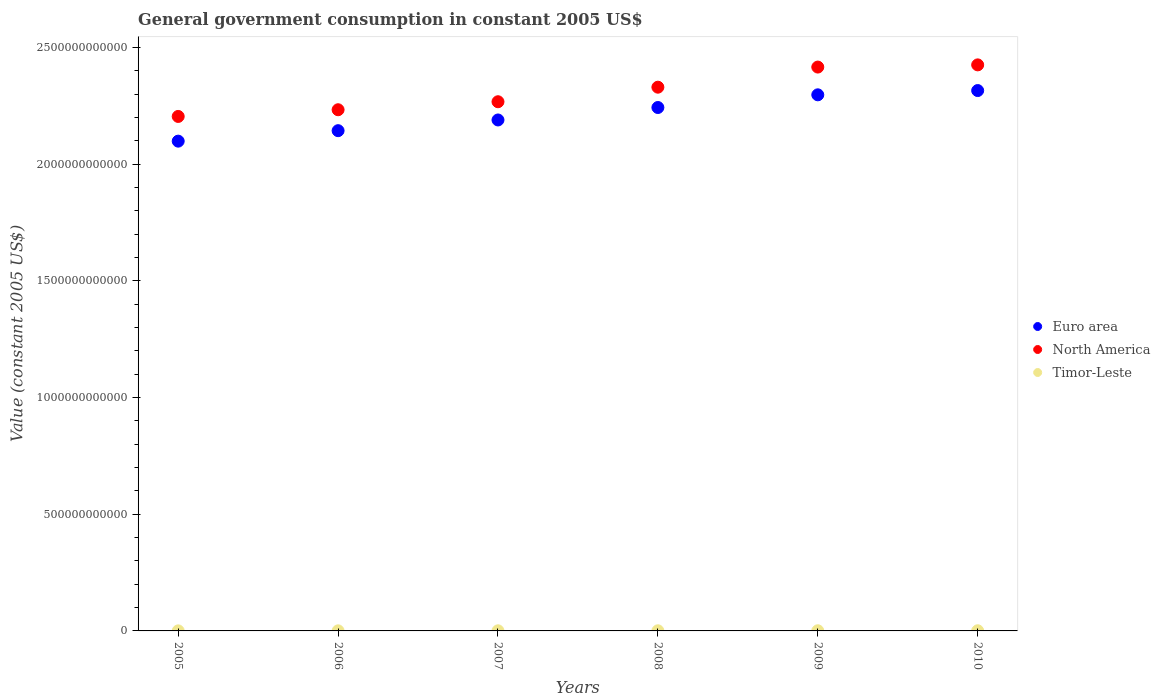What is the government conusmption in North America in 2010?
Give a very brief answer. 2.42e+12. Across all years, what is the maximum government conusmption in Euro area?
Your response must be concise. 2.31e+12. Across all years, what is the minimum government conusmption in North America?
Give a very brief answer. 2.20e+12. In which year was the government conusmption in Euro area minimum?
Provide a short and direct response. 2005. What is the total government conusmption in Euro area in the graph?
Give a very brief answer. 1.33e+13. What is the difference between the government conusmption in North America in 2006 and that in 2008?
Provide a short and direct response. -9.66e+1. What is the difference between the government conusmption in Euro area in 2008 and the government conusmption in Timor-Leste in 2009?
Offer a very short reply. 2.24e+12. What is the average government conusmption in Timor-Leste per year?
Offer a very short reply. 5.15e+08. In the year 2005, what is the difference between the government conusmption in North America and government conusmption in Euro area?
Offer a terse response. 1.06e+11. What is the ratio of the government conusmption in Timor-Leste in 2005 to that in 2007?
Ensure brevity in your answer.  0.48. What is the difference between the highest and the second highest government conusmption in Euro area?
Your answer should be compact. 1.83e+1. What is the difference between the highest and the lowest government conusmption in North America?
Your answer should be compact. 2.21e+11. Is the sum of the government conusmption in North America in 2007 and 2008 greater than the maximum government conusmption in Euro area across all years?
Give a very brief answer. Yes. Is it the case that in every year, the sum of the government conusmption in Timor-Leste and government conusmption in North America  is greater than the government conusmption in Euro area?
Offer a very short reply. Yes. Is the government conusmption in Timor-Leste strictly greater than the government conusmption in North America over the years?
Your answer should be very brief. No. How many dotlines are there?
Provide a short and direct response. 3. How many years are there in the graph?
Your response must be concise. 6. What is the difference between two consecutive major ticks on the Y-axis?
Your response must be concise. 5.00e+11. Are the values on the major ticks of Y-axis written in scientific E-notation?
Provide a short and direct response. No. Does the graph contain any zero values?
Make the answer very short. No. Does the graph contain grids?
Make the answer very short. No. How many legend labels are there?
Provide a succinct answer. 3. How are the legend labels stacked?
Give a very brief answer. Vertical. What is the title of the graph?
Ensure brevity in your answer.  General government consumption in constant 2005 US$. Does "Jamaica" appear as one of the legend labels in the graph?
Your answer should be very brief. No. What is the label or title of the Y-axis?
Your answer should be very brief. Value (constant 2005 US$). What is the Value (constant 2005 US$) in Euro area in 2005?
Offer a very short reply. 2.10e+12. What is the Value (constant 2005 US$) in North America in 2005?
Give a very brief answer. 2.20e+12. What is the Value (constant 2005 US$) in Timor-Leste in 2005?
Keep it short and to the point. 2.47e+08. What is the Value (constant 2005 US$) of Euro area in 2006?
Make the answer very short. 2.14e+12. What is the Value (constant 2005 US$) in North America in 2006?
Your answer should be compact. 2.23e+12. What is the Value (constant 2005 US$) in Timor-Leste in 2006?
Your answer should be compact. 3.63e+08. What is the Value (constant 2005 US$) of Euro area in 2007?
Your answer should be very brief. 2.19e+12. What is the Value (constant 2005 US$) in North America in 2007?
Your answer should be very brief. 2.27e+12. What is the Value (constant 2005 US$) in Timor-Leste in 2007?
Your answer should be compact. 5.18e+08. What is the Value (constant 2005 US$) of Euro area in 2008?
Ensure brevity in your answer.  2.24e+12. What is the Value (constant 2005 US$) of North America in 2008?
Provide a succinct answer. 2.33e+12. What is the Value (constant 2005 US$) in Timor-Leste in 2008?
Ensure brevity in your answer.  5.79e+08. What is the Value (constant 2005 US$) of Euro area in 2009?
Make the answer very short. 2.30e+12. What is the Value (constant 2005 US$) in North America in 2009?
Offer a terse response. 2.42e+12. What is the Value (constant 2005 US$) of Timor-Leste in 2009?
Give a very brief answer. 6.89e+08. What is the Value (constant 2005 US$) of Euro area in 2010?
Keep it short and to the point. 2.31e+12. What is the Value (constant 2005 US$) in North America in 2010?
Offer a very short reply. 2.42e+12. What is the Value (constant 2005 US$) of Timor-Leste in 2010?
Make the answer very short. 6.97e+08. Across all years, what is the maximum Value (constant 2005 US$) of Euro area?
Your response must be concise. 2.31e+12. Across all years, what is the maximum Value (constant 2005 US$) in North America?
Your answer should be very brief. 2.42e+12. Across all years, what is the maximum Value (constant 2005 US$) in Timor-Leste?
Keep it short and to the point. 6.97e+08. Across all years, what is the minimum Value (constant 2005 US$) of Euro area?
Your answer should be compact. 2.10e+12. Across all years, what is the minimum Value (constant 2005 US$) of North America?
Your answer should be compact. 2.20e+12. Across all years, what is the minimum Value (constant 2005 US$) in Timor-Leste?
Your answer should be very brief. 2.47e+08. What is the total Value (constant 2005 US$) in Euro area in the graph?
Make the answer very short. 1.33e+13. What is the total Value (constant 2005 US$) in North America in the graph?
Offer a terse response. 1.39e+13. What is the total Value (constant 2005 US$) in Timor-Leste in the graph?
Your response must be concise. 3.09e+09. What is the difference between the Value (constant 2005 US$) of Euro area in 2005 and that in 2006?
Offer a very short reply. -4.49e+1. What is the difference between the Value (constant 2005 US$) in North America in 2005 and that in 2006?
Provide a succinct answer. -2.87e+1. What is the difference between the Value (constant 2005 US$) of Timor-Leste in 2005 and that in 2006?
Offer a terse response. -1.16e+08. What is the difference between the Value (constant 2005 US$) in Euro area in 2005 and that in 2007?
Ensure brevity in your answer.  -9.07e+1. What is the difference between the Value (constant 2005 US$) in North America in 2005 and that in 2007?
Your response must be concise. -6.30e+1. What is the difference between the Value (constant 2005 US$) in Timor-Leste in 2005 and that in 2007?
Offer a terse response. -2.71e+08. What is the difference between the Value (constant 2005 US$) of Euro area in 2005 and that in 2008?
Offer a very short reply. -1.44e+11. What is the difference between the Value (constant 2005 US$) of North America in 2005 and that in 2008?
Provide a short and direct response. -1.25e+11. What is the difference between the Value (constant 2005 US$) in Timor-Leste in 2005 and that in 2008?
Make the answer very short. -3.32e+08. What is the difference between the Value (constant 2005 US$) in Euro area in 2005 and that in 2009?
Your answer should be compact. -1.98e+11. What is the difference between the Value (constant 2005 US$) in North America in 2005 and that in 2009?
Give a very brief answer. -2.12e+11. What is the difference between the Value (constant 2005 US$) of Timor-Leste in 2005 and that in 2009?
Keep it short and to the point. -4.42e+08. What is the difference between the Value (constant 2005 US$) of Euro area in 2005 and that in 2010?
Provide a succinct answer. -2.17e+11. What is the difference between the Value (constant 2005 US$) in North America in 2005 and that in 2010?
Your response must be concise. -2.21e+11. What is the difference between the Value (constant 2005 US$) of Timor-Leste in 2005 and that in 2010?
Your answer should be very brief. -4.50e+08. What is the difference between the Value (constant 2005 US$) of Euro area in 2006 and that in 2007?
Provide a succinct answer. -4.59e+1. What is the difference between the Value (constant 2005 US$) in North America in 2006 and that in 2007?
Your answer should be compact. -3.43e+1. What is the difference between the Value (constant 2005 US$) in Timor-Leste in 2006 and that in 2007?
Offer a very short reply. -1.55e+08. What is the difference between the Value (constant 2005 US$) of Euro area in 2006 and that in 2008?
Make the answer very short. -9.92e+1. What is the difference between the Value (constant 2005 US$) of North America in 2006 and that in 2008?
Give a very brief answer. -9.66e+1. What is the difference between the Value (constant 2005 US$) in Timor-Leste in 2006 and that in 2008?
Keep it short and to the point. -2.17e+08. What is the difference between the Value (constant 2005 US$) in Euro area in 2006 and that in 2009?
Your answer should be compact. -1.54e+11. What is the difference between the Value (constant 2005 US$) in North America in 2006 and that in 2009?
Provide a succinct answer. -1.83e+11. What is the difference between the Value (constant 2005 US$) of Timor-Leste in 2006 and that in 2009?
Offer a very short reply. -3.26e+08. What is the difference between the Value (constant 2005 US$) of Euro area in 2006 and that in 2010?
Provide a succinct answer. -1.72e+11. What is the difference between the Value (constant 2005 US$) in North America in 2006 and that in 2010?
Your response must be concise. -1.92e+11. What is the difference between the Value (constant 2005 US$) of Timor-Leste in 2006 and that in 2010?
Provide a succinct answer. -3.34e+08. What is the difference between the Value (constant 2005 US$) in Euro area in 2007 and that in 2008?
Your response must be concise. -5.34e+1. What is the difference between the Value (constant 2005 US$) of North America in 2007 and that in 2008?
Provide a short and direct response. -6.23e+1. What is the difference between the Value (constant 2005 US$) in Timor-Leste in 2007 and that in 2008?
Keep it short and to the point. -6.18e+07. What is the difference between the Value (constant 2005 US$) in Euro area in 2007 and that in 2009?
Provide a short and direct response. -1.08e+11. What is the difference between the Value (constant 2005 US$) in North America in 2007 and that in 2009?
Provide a short and direct response. -1.49e+11. What is the difference between the Value (constant 2005 US$) of Timor-Leste in 2007 and that in 2009?
Ensure brevity in your answer.  -1.72e+08. What is the difference between the Value (constant 2005 US$) of Euro area in 2007 and that in 2010?
Provide a short and direct response. -1.26e+11. What is the difference between the Value (constant 2005 US$) of North America in 2007 and that in 2010?
Offer a very short reply. -1.58e+11. What is the difference between the Value (constant 2005 US$) of Timor-Leste in 2007 and that in 2010?
Offer a terse response. -1.79e+08. What is the difference between the Value (constant 2005 US$) in Euro area in 2008 and that in 2009?
Give a very brief answer. -5.44e+1. What is the difference between the Value (constant 2005 US$) in North America in 2008 and that in 2009?
Your answer should be compact. -8.62e+1. What is the difference between the Value (constant 2005 US$) of Timor-Leste in 2008 and that in 2009?
Your answer should be very brief. -1.10e+08. What is the difference between the Value (constant 2005 US$) of Euro area in 2008 and that in 2010?
Provide a short and direct response. -7.26e+1. What is the difference between the Value (constant 2005 US$) in North America in 2008 and that in 2010?
Provide a short and direct response. -9.56e+1. What is the difference between the Value (constant 2005 US$) of Timor-Leste in 2008 and that in 2010?
Your answer should be very brief. -1.17e+08. What is the difference between the Value (constant 2005 US$) of Euro area in 2009 and that in 2010?
Give a very brief answer. -1.83e+1. What is the difference between the Value (constant 2005 US$) in North America in 2009 and that in 2010?
Ensure brevity in your answer.  -9.41e+09. What is the difference between the Value (constant 2005 US$) of Timor-Leste in 2009 and that in 2010?
Your response must be concise. -7.62e+06. What is the difference between the Value (constant 2005 US$) of Euro area in 2005 and the Value (constant 2005 US$) of North America in 2006?
Make the answer very short. -1.35e+11. What is the difference between the Value (constant 2005 US$) in Euro area in 2005 and the Value (constant 2005 US$) in Timor-Leste in 2006?
Offer a very short reply. 2.10e+12. What is the difference between the Value (constant 2005 US$) of North America in 2005 and the Value (constant 2005 US$) of Timor-Leste in 2006?
Keep it short and to the point. 2.20e+12. What is the difference between the Value (constant 2005 US$) in Euro area in 2005 and the Value (constant 2005 US$) in North America in 2007?
Ensure brevity in your answer.  -1.69e+11. What is the difference between the Value (constant 2005 US$) in Euro area in 2005 and the Value (constant 2005 US$) in Timor-Leste in 2007?
Your answer should be very brief. 2.10e+12. What is the difference between the Value (constant 2005 US$) of North America in 2005 and the Value (constant 2005 US$) of Timor-Leste in 2007?
Give a very brief answer. 2.20e+12. What is the difference between the Value (constant 2005 US$) in Euro area in 2005 and the Value (constant 2005 US$) in North America in 2008?
Offer a terse response. -2.31e+11. What is the difference between the Value (constant 2005 US$) of Euro area in 2005 and the Value (constant 2005 US$) of Timor-Leste in 2008?
Keep it short and to the point. 2.10e+12. What is the difference between the Value (constant 2005 US$) of North America in 2005 and the Value (constant 2005 US$) of Timor-Leste in 2008?
Offer a terse response. 2.20e+12. What is the difference between the Value (constant 2005 US$) of Euro area in 2005 and the Value (constant 2005 US$) of North America in 2009?
Offer a very short reply. -3.17e+11. What is the difference between the Value (constant 2005 US$) in Euro area in 2005 and the Value (constant 2005 US$) in Timor-Leste in 2009?
Keep it short and to the point. 2.10e+12. What is the difference between the Value (constant 2005 US$) of North America in 2005 and the Value (constant 2005 US$) of Timor-Leste in 2009?
Your answer should be very brief. 2.20e+12. What is the difference between the Value (constant 2005 US$) in Euro area in 2005 and the Value (constant 2005 US$) in North America in 2010?
Your response must be concise. -3.27e+11. What is the difference between the Value (constant 2005 US$) of Euro area in 2005 and the Value (constant 2005 US$) of Timor-Leste in 2010?
Offer a terse response. 2.10e+12. What is the difference between the Value (constant 2005 US$) of North America in 2005 and the Value (constant 2005 US$) of Timor-Leste in 2010?
Your answer should be compact. 2.20e+12. What is the difference between the Value (constant 2005 US$) of Euro area in 2006 and the Value (constant 2005 US$) of North America in 2007?
Your answer should be compact. -1.24e+11. What is the difference between the Value (constant 2005 US$) of Euro area in 2006 and the Value (constant 2005 US$) of Timor-Leste in 2007?
Provide a succinct answer. 2.14e+12. What is the difference between the Value (constant 2005 US$) of North America in 2006 and the Value (constant 2005 US$) of Timor-Leste in 2007?
Your response must be concise. 2.23e+12. What is the difference between the Value (constant 2005 US$) of Euro area in 2006 and the Value (constant 2005 US$) of North America in 2008?
Offer a very short reply. -1.86e+11. What is the difference between the Value (constant 2005 US$) of Euro area in 2006 and the Value (constant 2005 US$) of Timor-Leste in 2008?
Provide a succinct answer. 2.14e+12. What is the difference between the Value (constant 2005 US$) of North America in 2006 and the Value (constant 2005 US$) of Timor-Leste in 2008?
Your response must be concise. 2.23e+12. What is the difference between the Value (constant 2005 US$) in Euro area in 2006 and the Value (constant 2005 US$) in North America in 2009?
Give a very brief answer. -2.72e+11. What is the difference between the Value (constant 2005 US$) of Euro area in 2006 and the Value (constant 2005 US$) of Timor-Leste in 2009?
Provide a short and direct response. 2.14e+12. What is the difference between the Value (constant 2005 US$) of North America in 2006 and the Value (constant 2005 US$) of Timor-Leste in 2009?
Your answer should be very brief. 2.23e+12. What is the difference between the Value (constant 2005 US$) of Euro area in 2006 and the Value (constant 2005 US$) of North America in 2010?
Provide a short and direct response. -2.82e+11. What is the difference between the Value (constant 2005 US$) in Euro area in 2006 and the Value (constant 2005 US$) in Timor-Leste in 2010?
Make the answer very short. 2.14e+12. What is the difference between the Value (constant 2005 US$) of North America in 2006 and the Value (constant 2005 US$) of Timor-Leste in 2010?
Your answer should be very brief. 2.23e+12. What is the difference between the Value (constant 2005 US$) of Euro area in 2007 and the Value (constant 2005 US$) of North America in 2008?
Keep it short and to the point. -1.40e+11. What is the difference between the Value (constant 2005 US$) in Euro area in 2007 and the Value (constant 2005 US$) in Timor-Leste in 2008?
Offer a terse response. 2.19e+12. What is the difference between the Value (constant 2005 US$) of North America in 2007 and the Value (constant 2005 US$) of Timor-Leste in 2008?
Provide a succinct answer. 2.27e+12. What is the difference between the Value (constant 2005 US$) of Euro area in 2007 and the Value (constant 2005 US$) of North America in 2009?
Provide a succinct answer. -2.27e+11. What is the difference between the Value (constant 2005 US$) of Euro area in 2007 and the Value (constant 2005 US$) of Timor-Leste in 2009?
Your answer should be compact. 2.19e+12. What is the difference between the Value (constant 2005 US$) of North America in 2007 and the Value (constant 2005 US$) of Timor-Leste in 2009?
Offer a terse response. 2.27e+12. What is the difference between the Value (constant 2005 US$) of Euro area in 2007 and the Value (constant 2005 US$) of North America in 2010?
Your response must be concise. -2.36e+11. What is the difference between the Value (constant 2005 US$) of Euro area in 2007 and the Value (constant 2005 US$) of Timor-Leste in 2010?
Keep it short and to the point. 2.19e+12. What is the difference between the Value (constant 2005 US$) in North America in 2007 and the Value (constant 2005 US$) in Timor-Leste in 2010?
Offer a terse response. 2.27e+12. What is the difference between the Value (constant 2005 US$) in Euro area in 2008 and the Value (constant 2005 US$) in North America in 2009?
Give a very brief answer. -1.73e+11. What is the difference between the Value (constant 2005 US$) in Euro area in 2008 and the Value (constant 2005 US$) in Timor-Leste in 2009?
Keep it short and to the point. 2.24e+12. What is the difference between the Value (constant 2005 US$) of North America in 2008 and the Value (constant 2005 US$) of Timor-Leste in 2009?
Your answer should be compact. 2.33e+12. What is the difference between the Value (constant 2005 US$) in Euro area in 2008 and the Value (constant 2005 US$) in North America in 2010?
Your answer should be compact. -1.83e+11. What is the difference between the Value (constant 2005 US$) in Euro area in 2008 and the Value (constant 2005 US$) in Timor-Leste in 2010?
Make the answer very short. 2.24e+12. What is the difference between the Value (constant 2005 US$) of North America in 2008 and the Value (constant 2005 US$) of Timor-Leste in 2010?
Your answer should be very brief. 2.33e+12. What is the difference between the Value (constant 2005 US$) in Euro area in 2009 and the Value (constant 2005 US$) in North America in 2010?
Provide a succinct answer. -1.28e+11. What is the difference between the Value (constant 2005 US$) in Euro area in 2009 and the Value (constant 2005 US$) in Timor-Leste in 2010?
Give a very brief answer. 2.30e+12. What is the difference between the Value (constant 2005 US$) in North America in 2009 and the Value (constant 2005 US$) in Timor-Leste in 2010?
Provide a succinct answer. 2.41e+12. What is the average Value (constant 2005 US$) of Euro area per year?
Offer a terse response. 2.21e+12. What is the average Value (constant 2005 US$) in North America per year?
Your answer should be compact. 2.31e+12. What is the average Value (constant 2005 US$) in Timor-Leste per year?
Keep it short and to the point. 5.15e+08. In the year 2005, what is the difference between the Value (constant 2005 US$) in Euro area and Value (constant 2005 US$) in North America?
Your response must be concise. -1.06e+11. In the year 2005, what is the difference between the Value (constant 2005 US$) in Euro area and Value (constant 2005 US$) in Timor-Leste?
Keep it short and to the point. 2.10e+12. In the year 2005, what is the difference between the Value (constant 2005 US$) of North America and Value (constant 2005 US$) of Timor-Leste?
Offer a terse response. 2.20e+12. In the year 2006, what is the difference between the Value (constant 2005 US$) in Euro area and Value (constant 2005 US$) in North America?
Ensure brevity in your answer.  -8.97e+1. In the year 2006, what is the difference between the Value (constant 2005 US$) in Euro area and Value (constant 2005 US$) in Timor-Leste?
Make the answer very short. 2.14e+12. In the year 2006, what is the difference between the Value (constant 2005 US$) of North America and Value (constant 2005 US$) of Timor-Leste?
Your answer should be compact. 2.23e+12. In the year 2007, what is the difference between the Value (constant 2005 US$) in Euro area and Value (constant 2005 US$) in North America?
Ensure brevity in your answer.  -7.81e+1. In the year 2007, what is the difference between the Value (constant 2005 US$) in Euro area and Value (constant 2005 US$) in Timor-Leste?
Keep it short and to the point. 2.19e+12. In the year 2007, what is the difference between the Value (constant 2005 US$) of North America and Value (constant 2005 US$) of Timor-Leste?
Keep it short and to the point. 2.27e+12. In the year 2008, what is the difference between the Value (constant 2005 US$) of Euro area and Value (constant 2005 US$) of North America?
Make the answer very short. -8.71e+1. In the year 2008, what is the difference between the Value (constant 2005 US$) of Euro area and Value (constant 2005 US$) of Timor-Leste?
Ensure brevity in your answer.  2.24e+12. In the year 2008, what is the difference between the Value (constant 2005 US$) of North America and Value (constant 2005 US$) of Timor-Leste?
Ensure brevity in your answer.  2.33e+12. In the year 2009, what is the difference between the Value (constant 2005 US$) of Euro area and Value (constant 2005 US$) of North America?
Your answer should be very brief. -1.19e+11. In the year 2009, what is the difference between the Value (constant 2005 US$) of Euro area and Value (constant 2005 US$) of Timor-Leste?
Give a very brief answer. 2.30e+12. In the year 2009, what is the difference between the Value (constant 2005 US$) in North America and Value (constant 2005 US$) in Timor-Leste?
Give a very brief answer. 2.41e+12. In the year 2010, what is the difference between the Value (constant 2005 US$) in Euro area and Value (constant 2005 US$) in North America?
Ensure brevity in your answer.  -1.10e+11. In the year 2010, what is the difference between the Value (constant 2005 US$) of Euro area and Value (constant 2005 US$) of Timor-Leste?
Provide a succinct answer. 2.31e+12. In the year 2010, what is the difference between the Value (constant 2005 US$) of North America and Value (constant 2005 US$) of Timor-Leste?
Your answer should be very brief. 2.42e+12. What is the ratio of the Value (constant 2005 US$) in Euro area in 2005 to that in 2006?
Your response must be concise. 0.98. What is the ratio of the Value (constant 2005 US$) in North America in 2005 to that in 2006?
Keep it short and to the point. 0.99. What is the ratio of the Value (constant 2005 US$) in Timor-Leste in 2005 to that in 2006?
Your answer should be compact. 0.68. What is the ratio of the Value (constant 2005 US$) in Euro area in 2005 to that in 2007?
Ensure brevity in your answer.  0.96. What is the ratio of the Value (constant 2005 US$) in North America in 2005 to that in 2007?
Offer a very short reply. 0.97. What is the ratio of the Value (constant 2005 US$) of Timor-Leste in 2005 to that in 2007?
Provide a succinct answer. 0.48. What is the ratio of the Value (constant 2005 US$) of Euro area in 2005 to that in 2008?
Provide a succinct answer. 0.94. What is the ratio of the Value (constant 2005 US$) in North America in 2005 to that in 2008?
Your answer should be compact. 0.95. What is the ratio of the Value (constant 2005 US$) of Timor-Leste in 2005 to that in 2008?
Your answer should be very brief. 0.43. What is the ratio of the Value (constant 2005 US$) in Euro area in 2005 to that in 2009?
Give a very brief answer. 0.91. What is the ratio of the Value (constant 2005 US$) of North America in 2005 to that in 2009?
Your response must be concise. 0.91. What is the ratio of the Value (constant 2005 US$) in Timor-Leste in 2005 to that in 2009?
Your answer should be very brief. 0.36. What is the ratio of the Value (constant 2005 US$) of Euro area in 2005 to that in 2010?
Give a very brief answer. 0.91. What is the ratio of the Value (constant 2005 US$) of North America in 2005 to that in 2010?
Your answer should be very brief. 0.91. What is the ratio of the Value (constant 2005 US$) in Timor-Leste in 2005 to that in 2010?
Provide a short and direct response. 0.35. What is the ratio of the Value (constant 2005 US$) in North America in 2006 to that in 2007?
Keep it short and to the point. 0.98. What is the ratio of the Value (constant 2005 US$) in Timor-Leste in 2006 to that in 2007?
Make the answer very short. 0.7. What is the ratio of the Value (constant 2005 US$) in Euro area in 2006 to that in 2008?
Give a very brief answer. 0.96. What is the ratio of the Value (constant 2005 US$) in North America in 2006 to that in 2008?
Ensure brevity in your answer.  0.96. What is the ratio of the Value (constant 2005 US$) in Timor-Leste in 2006 to that in 2008?
Ensure brevity in your answer.  0.63. What is the ratio of the Value (constant 2005 US$) in Euro area in 2006 to that in 2009?
Provide a short and direct response. 0.93. What is the ratio of the Value (constant 2005 US$) in North America in 2006 to that in 2009?
Make the answer very short. 0.92. What is the ratio of the Value (constant 2005 US$) of Timor-Leste in 2006 to that in 2009?
Make the answer very short. 0.53. What is the ratio of the Value (constant 2005 US$) of Euro area in 2006 to that in 2010?
Your answer should be compact. 0.93. What is the ratio of the Value (constant 2005 US$) in North America in 2006 to that in 2010?
Make the answer very short. 0.92. What is the ratio of the Value (constant 2005 US$) in Timor-Leste in 2006 to that in 2010?
Your response must be concise. 0.52. What is the ratio of the Value (constant 2005 US$) of Euro area in 2007 to that in 2008?
Give a very brief answer. 0.98. What is the ratio of the Value (constant 2005 US$) in North America in 2007 to that in 2008?
Provide a short and direct response. 0.97. What is the ratio of the Value (constant 2005 US$) of Timor-Leste in 2007 to that in 2008?
Offer a terse response. 0.89. What is the ratio of the Value (constant 2005 US$) of Euro area in 2007 to that in 2009?
Your answer should be compact. 0.95. What is the ratio of the Value (constant 2005 US$) of North America in 2007 to that in 2009?
Provide a succinct answer. 0.94. What is the ratio of the Value (constant 2005 US$) of Timor-Leste in 2007 to that in 2009?
Provide a short and direct response. 0.75. What is the ratio of the Value (constant 2005 US$) in Euro area in 2007 to that in 2010?
Offer a very short reply. 0.95. What is the ratio of the Value (constant 2005 US$) of North America in 2007 to that in 2010?
Keep it short and to the point. 0.93. What is the ratio of the Value (constant 2005 US$) of Timor-Leste in 2007 to that in 2010?
Provide a short and direct response. 0.74. What is the ratio of the Value (constant 2005 US$) in Euro area in 2008 to that in 2009?
Provide a succinct answer. 0.98. What is the ratio of the Value (constant 2005 US$) in Timor-Leste in 2008 to that in 2009?
Keep it short and to the point. 0.84. What is the ratio of the Value (constant 2005 US$) of Euro area in 2008 to that in 2010?
Keep it short and to the point. 0.97. What is the ratio of the Value (constant 2005 US$) in North America in 2008 to that in 2010?
Your response must be concise. 0.96. What is the ratio of the Value (constant 2005 US$) in Timor-Leste in 2008 to that in 2010?
Your answer should be compact. 0.83. What is the ratio of the Value (constant 2005 US$) of North America in 2009 to that in 2010?
Make the answer very short. 1. What is the difference between the highest and the second highest Value (constant 2005 US$) in Euro area?
Make the answer very short. 1.83e+1. What is the difference between the highest and the second highest Value (constant 2005 US$) in North America?
Your answer should be very brief. 9.41e+09. What is the difference between the highest and the second highest Value (constant 2005 US$) in Timor-Leste?
Keep it short and to the point. 7.62e+06. What is the difference between the highest and the lowest Value (constant 2005 US$) of Euro area?
Your answer should be compact. 2.17e+11. What is the difference between the highest and the lowest Value (constant 2005 US$) of North America?
Provide a short and direct response. 2.21e+11. What is the difference between the highest and the lowest Value (constant 2005 US$) in Timor-Leste?
Provide a succinct answer. 4.50e+08. 